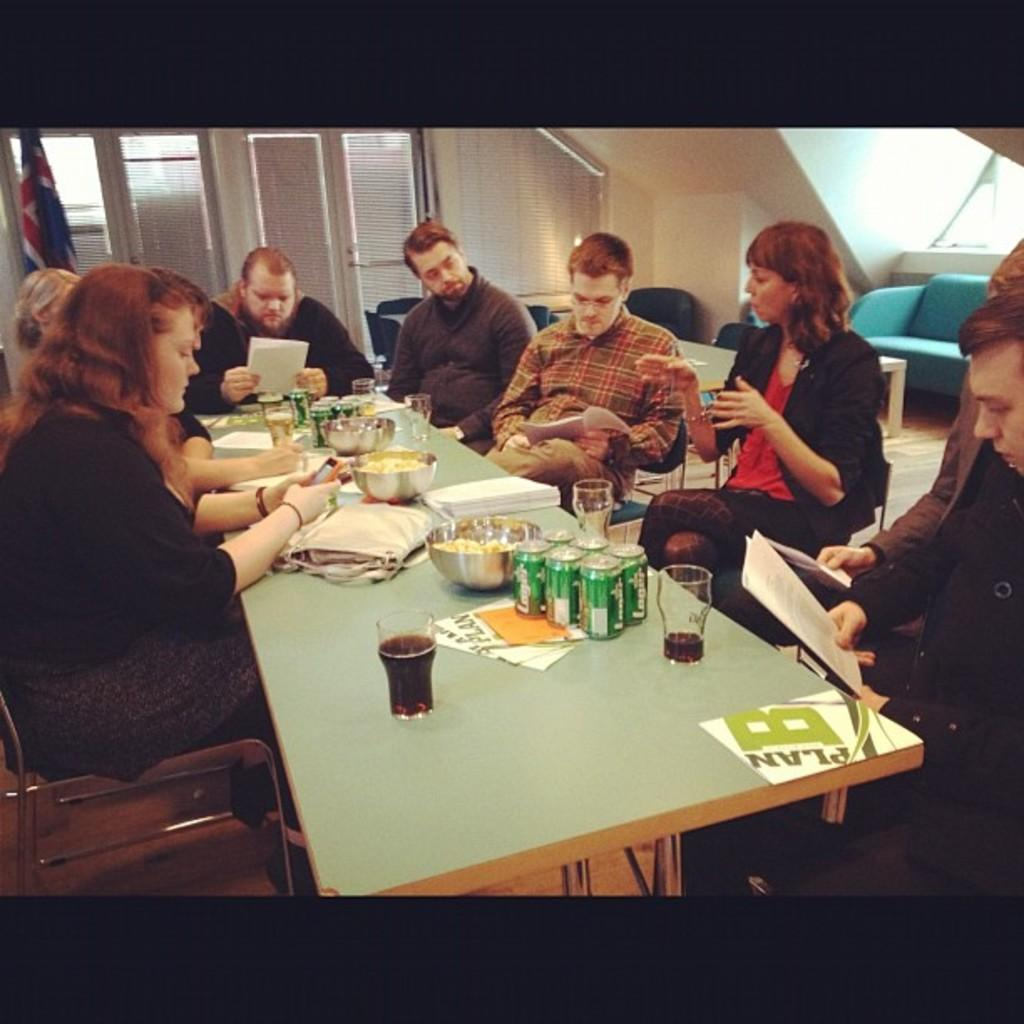How many people are in the image? There is a group of people in the image. What are the people doing in the image? The people are sitting on chairs. What is on the table in the image? There is a bowl, a glass, a cloth, and a food item on the table. What can be seen in the background of the image? There is a curtain and a window visible in the background. What type of plantation can be seen in the image? There is no plantation visible in the image. How many grains of rice are present on the table in the image? There is no rice visible on the table in the image. 